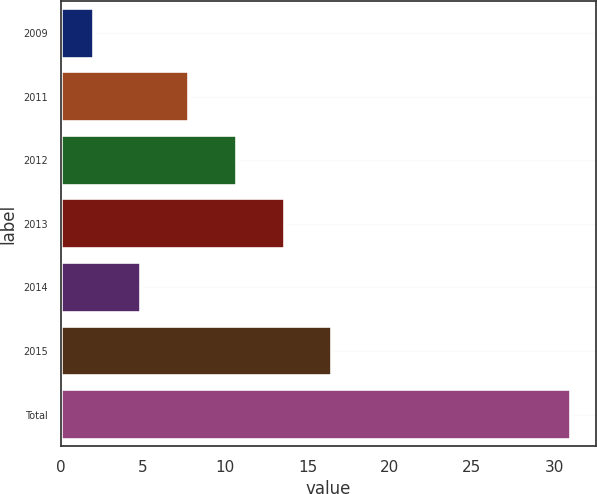Convert chart to OTSL. <chart><loc_0><loc_0><loc_500><loc_500><bar_chart><fcel>2009<fcel>2011<fcel>2012<fcel>2013<fcel>2014<fcel>2015<fcel>Total<nl><fcel>2<fcel>7.8<fcel>10.7<fcel>13.6<fcel>4.9<fcel>16.5<fcel>31<nl></chart> 